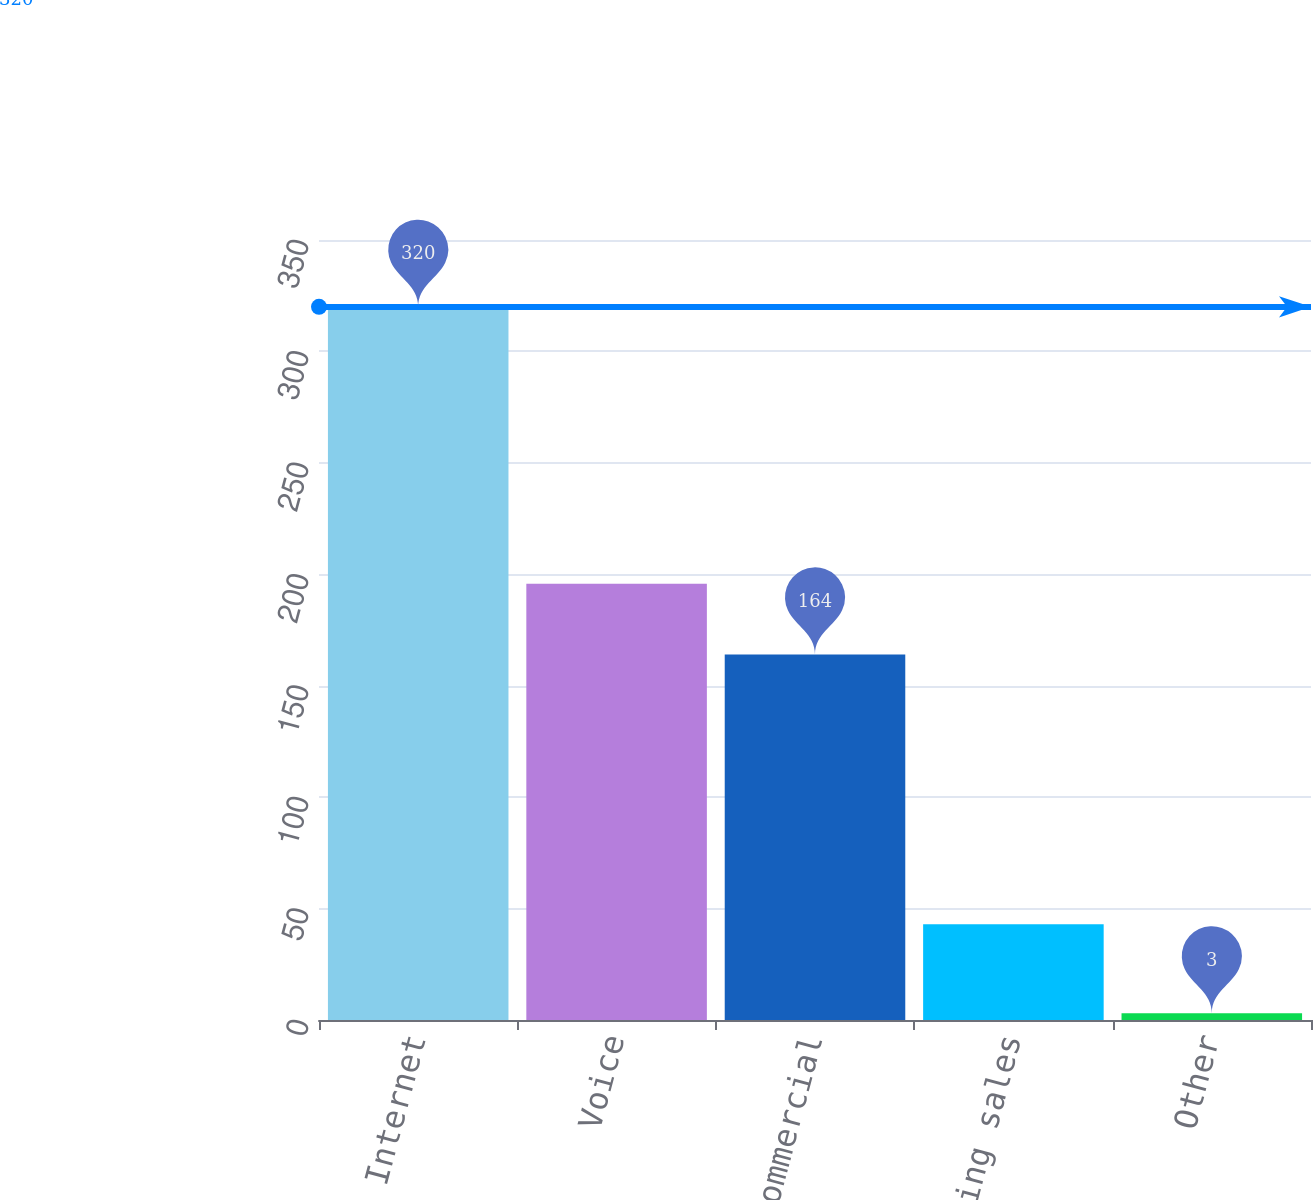Convert chart. <chart><loc_0><loc_0><loc_500><loc_500><bar_chart><fcel>Internet<fcel>Voice<fcel>Commercial<fcel>Advertising sales<fcel>Other<nl><fcel>320<fcel>195.7<fcel>164<fcel>43<fcel>3<nl></chart> 